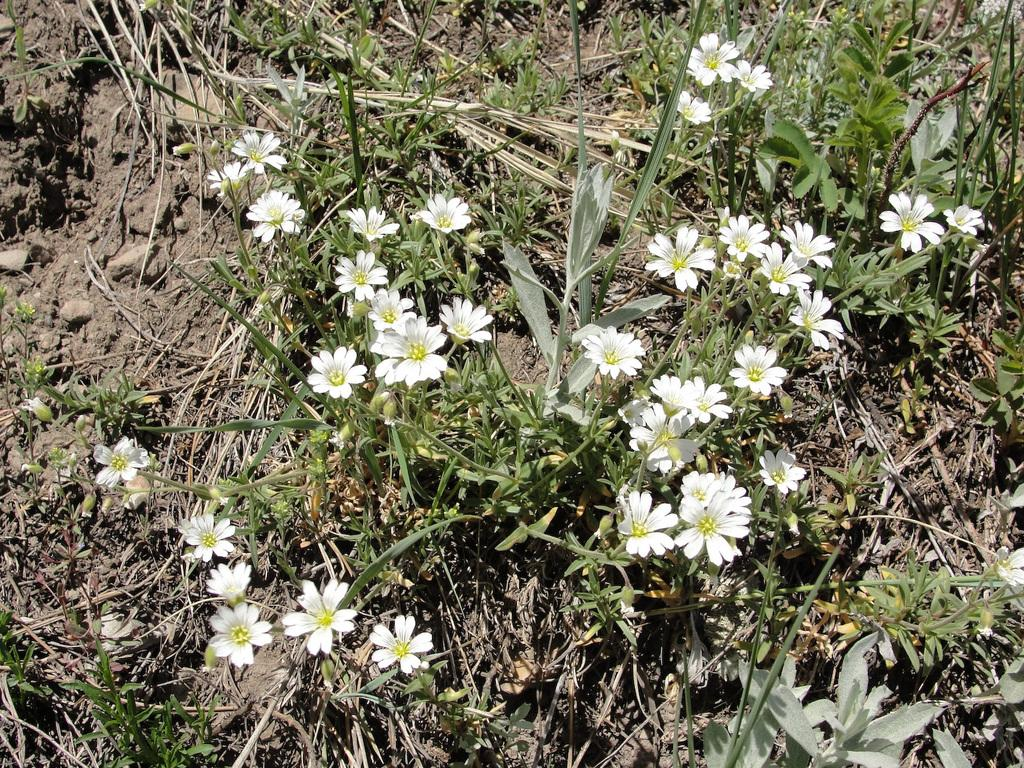What type of plant is visible in the image? There is a plant in the image. What distinguishing feature can be observed about the plant's flowers? The plant has many white flowers. Where is the plant located in the image? The plant is on a dry grassland. Can you see a throne made of toadstools in the image? No, there is no throne or toadstools present in the image. 